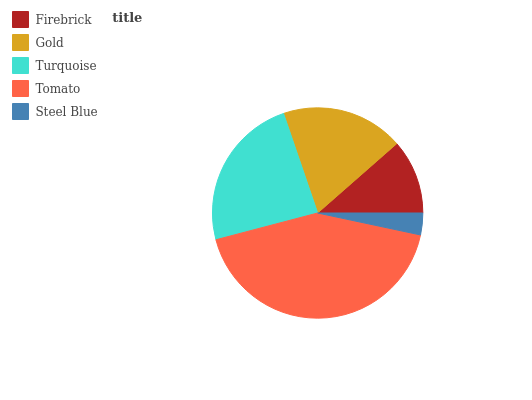Is Steel Blue the minimum?
Answer yes or no. Yes. Is Tomato the maximum?
Answer yes or no. Yes. Is Gold the minimum?
Answer yes or no. No. Is Gold the maximum?
Answer yes or no. No. Is Gold greater than Firebrick?
Answer yes or no. Yes. Is Firebrick less than Gold?
Answer yes or no. Yes. Is Firebrick greater than Gold?
Answer yes or no. No. Is Gold less than Firebrick?
Answer yes or no. No. Is Gold the high median?
Answer yes or no. Yes. Is Gold the low median?
Answer yes or no. Yes. Is Turquoise the high median?
Answer yes or no. No. Is Turquoise the low median?
Answer yes or no. No. 